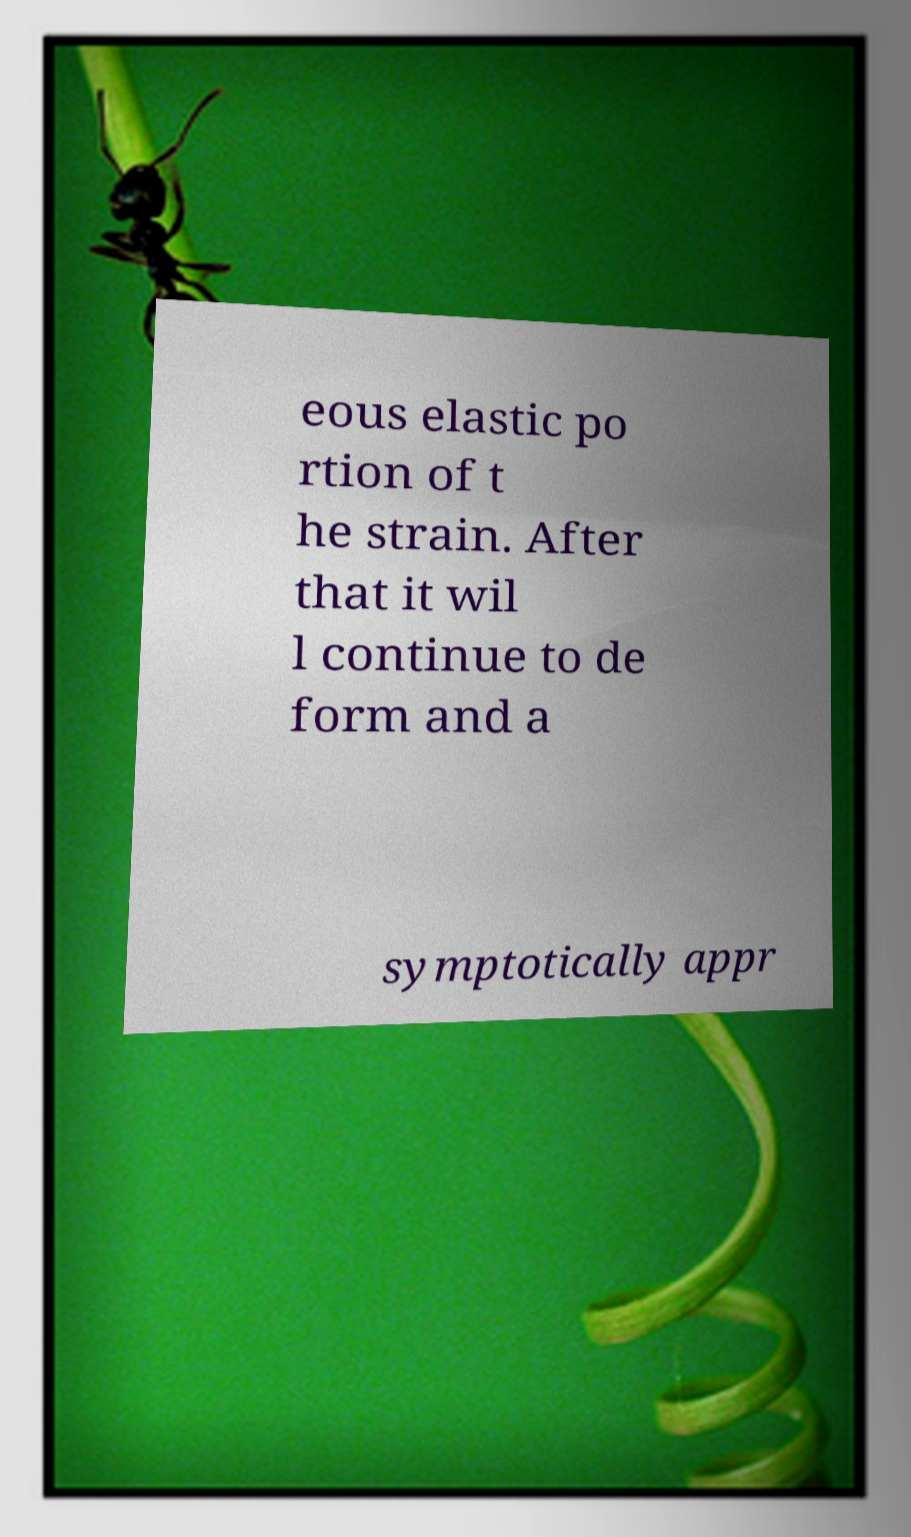Could you assist in decoding the text presented in this image and type it out clearly? eous elastic po rtion of t he strain. After that it wil l continue to de form and a symptotically appr 